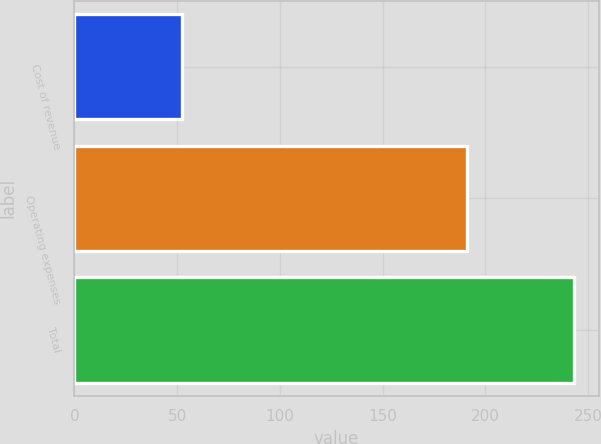Convert chart to OTSL. <chart><loc_0><loc_0><loc_500><loc_500><bar_chart><fcel>Cost of revenue<fcel>Operating expenses<fcel>Total<nl><fcel>52.2<fcel>190.9<fcel>243.1<nl></chart> 